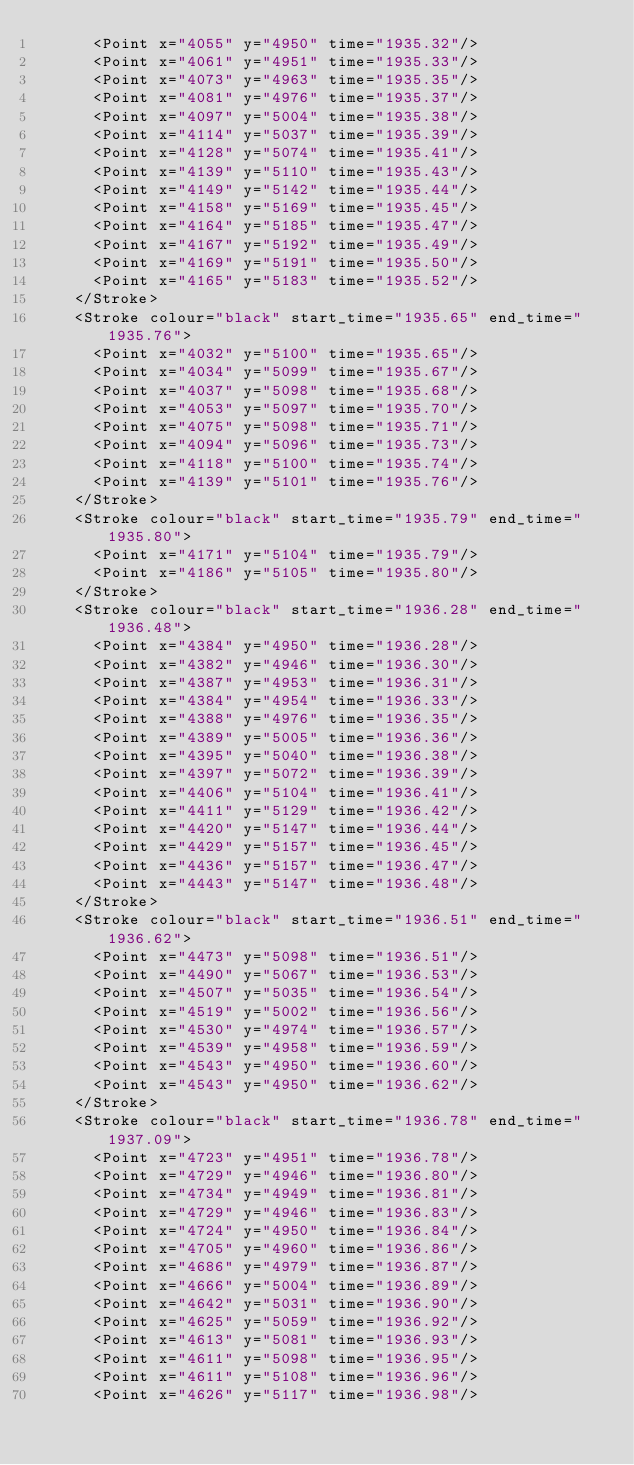<code> <loc_0><loc_0><loc_500><loc_500><_XML_>      <Point x="4055" y="4950" time="1935.32"/>
      <Point x="4061" y="4951" time="1935.33"/>
      <Point x="4073" y="4963" time="1935.35"/>
      <Point x="4081" y="4976" time="1935.37"/>
      <Point x="4097" y="5004" time="1935.38"/>
      <Point x="4114" y="5037" time="1935.39"/>
      <Point x="4128" y="5074" time="1935.41"/>
      <Point x="4139" y="5110" time="1935.43"/>
      <Point x="4149" y="5142" time="1935.44"/>
      <Point x="4158" y="5169" time="1935.45"/>
      <Point x="4164" y="5185" time="1935.47"/>
      <Point x="4167" y="5192" time="1935.49"/>
      <Point x="4169" y="5191" time="1935.50"/>
      <Point x="4165" y="5183" time="1935.52"/>
    </Stroke>
    <Stroke colour="black" start_time="1935.65" end_time="1935.76">
      <Point x="4032" y="5100" time="1935.65"/>
      <Point x="4034" y="5099" time="1935.67"/>
      <Point x="4037" y="5098" time="1935.68"/>
      <Point x="4053" y="5097" time="1935.70"/>
      <Point x="4075" y="5098" time="1935.71"/>
      <Point x="4094" y="5096" time="1935.73"/>
      <Point x="4118" y="5100" time="1935.74"/>
      <Point x="4139" y="5101" time="1935.76"/>
    </Stroke>
    <Stroke colour="black" start_time="1935.79" end_time="1935.80">
      <Point x="4171" y="5104" time="1935.79"/>
      <Point x="4186" y="5105" time="1935.80"/>
    </Stroke>
    <Stroke colour="black" start_time="1936.28" end_time="1936.48">
      <Point x="4384" y="4950" time="1936.28"/>
      <Point x="4382" y="4946" time="1936.30"/>
      <Point x="4387" y="4953" time="1936.31"/>
      <Point x="4384" y="4954" time="1936.33"/>
      <Point x="4388" y="4976" time="1936.35"/>
      <Point x="4389" y="5005" time="1936.36"/>
      <Point x="4395" y="5040" time="1936.38"/>
      <Point x="4397" y="5072" time="1936.39"/>
      <Point x="4406" y="5104" time="1936.41"/>
      <Point x="4411" y="5129" time="1936.42"/>
      <Point x="4420" y="5147" time="1936.44"/>
      <Point x="4429" y="5157" time="1936.45"/>
      <Point x="4436" y="5157" time="1936.47"/>
      <Point x="4443" y="5147" time="1936.48"/>
    </Stroke>
    <Stroke colour="black" start_time="1936.51" end_time="1936.62">
      <Point x="4473" y="5098" time="1936.51"/>
      <Point x="4490" y="5067" time="1936.53"/>
      <Point x="4507" y="5035" time="1936.54"/>
      <Point x="4519" y="5002" time="1936.56"/>
      <Point x="4530" y="4974" time="1936.57"/>
      <Point x="4539" y="4958" time="1936.59"/>
      <Point x="4543" y="4950" time="1936.60"/>
      <Point x="4543" y="4950" time="1936.62"/>
    </Stroke>
    <Stroke colour="black" start_time="1936.78" end_time="1937.09">
      <Point x="4723" y="4951" time="1936.78"/>
      <Point x="4729" y="4946" time="1936.80"/>
      <Point x="4734" y="4949" time="1936.81"/>
      <Point x="4729" y="4946" time="1936.83"/>
      <Point x="4724" y="4950" time="1936.84"/>
      <Point x="4705" y="4960" time="1936.86"/>
      <Point x="4686" y="4979" time="1936.87"/>
      <Point x="4666" y="5004" time="1936.89"/>
      <Point x="4642" y="5031" time="1936.90"/>
      <Point x="4625" y="5059" time="1936.92"/>
      <Point x="4613" y="5081" time="1936.93"/>
      <Point x="4611" y="5098" time="1936.95"/>
      <Point x="4611" y="5108" time="1936.96"/>
      <Point x="4626" y="5117" time="1936.98"/></code> 